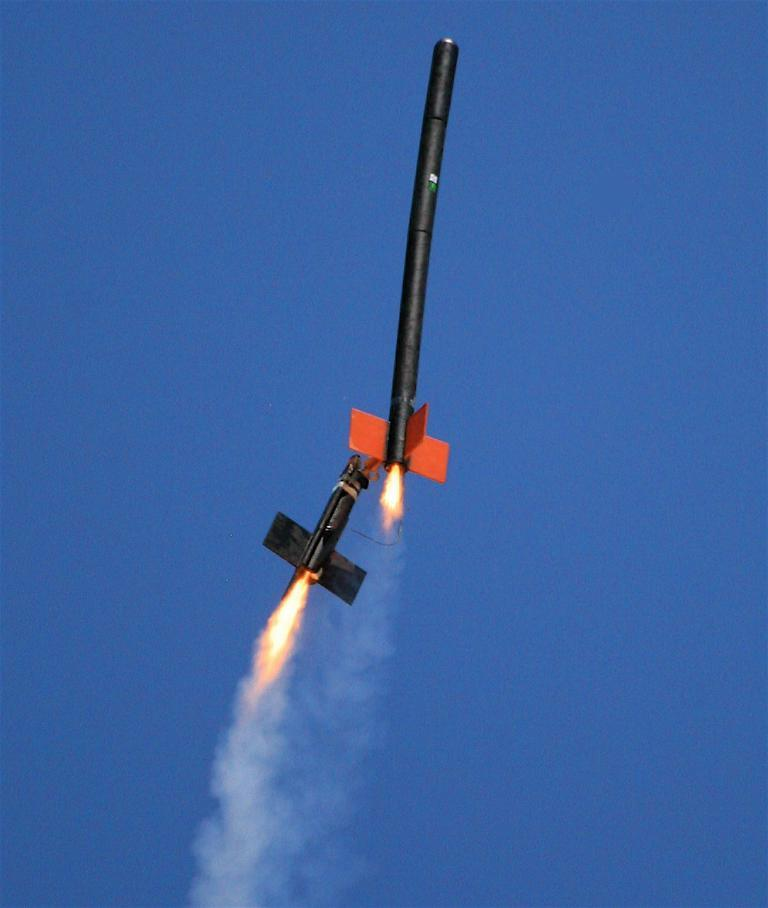What are the two black objects in the air? The two black objects in the air are not specified in the facts provided. What can be seen in the background of the image? The sky is visible in the image. What color is the sky in the image? The sky is blue in the image. What is the caption of the image? There is no caption provided in the image. Can you hear the song being played in the image? There is no sound or song present in the image. 